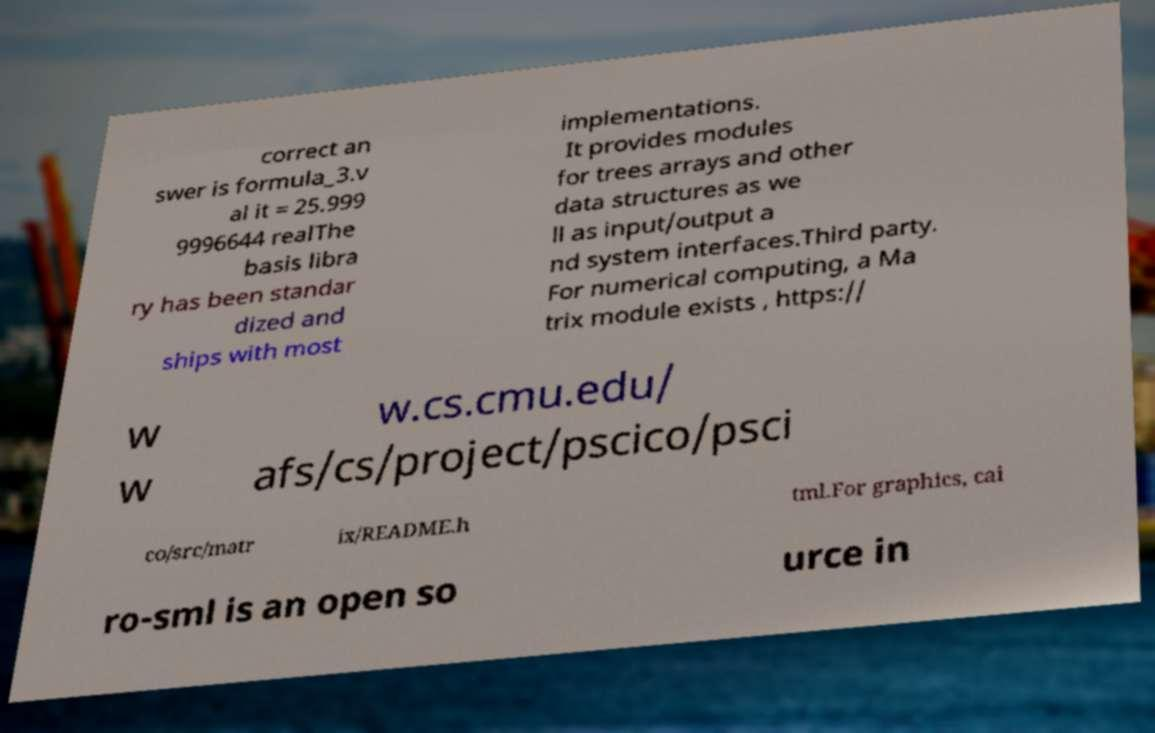Please read and relay the text visible in this image. What does it say? correct an swer is formula_3.v al it = 25.999 9996644 realThe basis libra ry has been standar dized and ships with most implementations. It provides modules for trees arrays and other data structures as we ll as input/output a nd system interfaces.Third party. For numerical computing, a Ma trix module exists , https:// w w w.cs.cmu.edu/ afs/cs/project/pscico/psci co/src/matr ix/README.h tml.For graphics, cai ro-sml is an open so urce in 